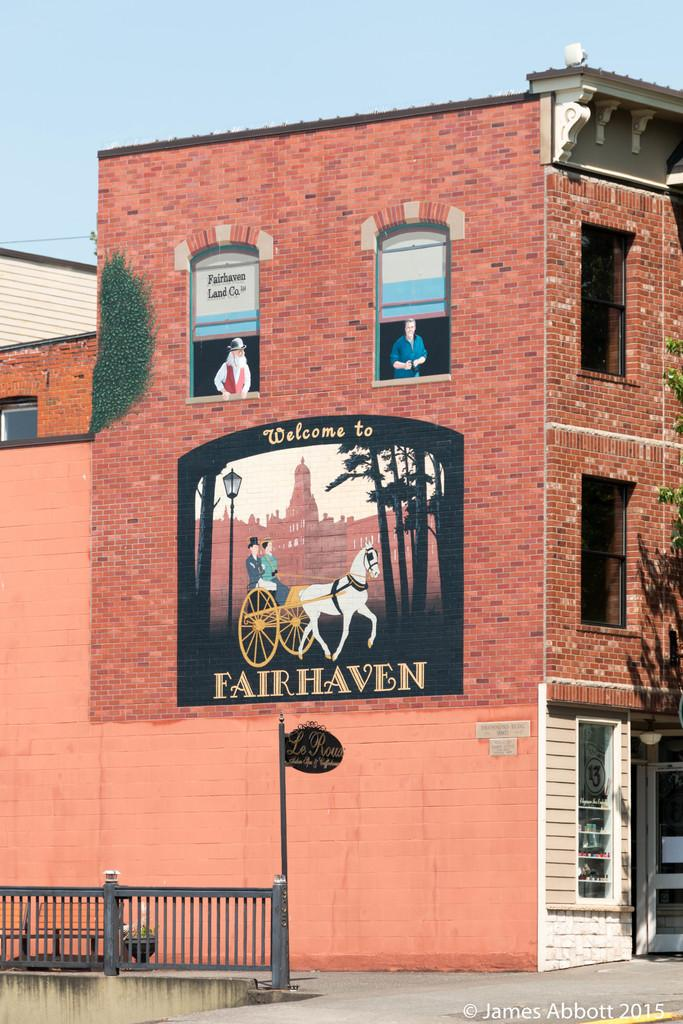What type of structure is visible in the image? There is a building in the image. What is attached to the building? There is a poster on the building. What type of barrier can be seen in the image? There is a fence in the image. What color is the sky in the image? The sky is blue in the image. What type of leather can be seen on the knife in the image? There is no knife or leather present in the image. How many visitors are visible in the image? There is no mention of visitors in the image; it only features a building, a poster, a fence, and a blue sky. 